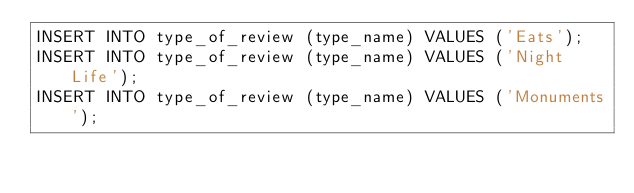Convert code to text. <code><loc_0><loc_0><loc_500><loc_500><_SQL_>INSERT INTO type_of_review (type_name) VALUES ('Eats');
INSERT INTO type_of_review (type_name) VALUES ('Night Life');
INSERT INTO type_of_review (type_name) VALUES ('Monuments');</code> 